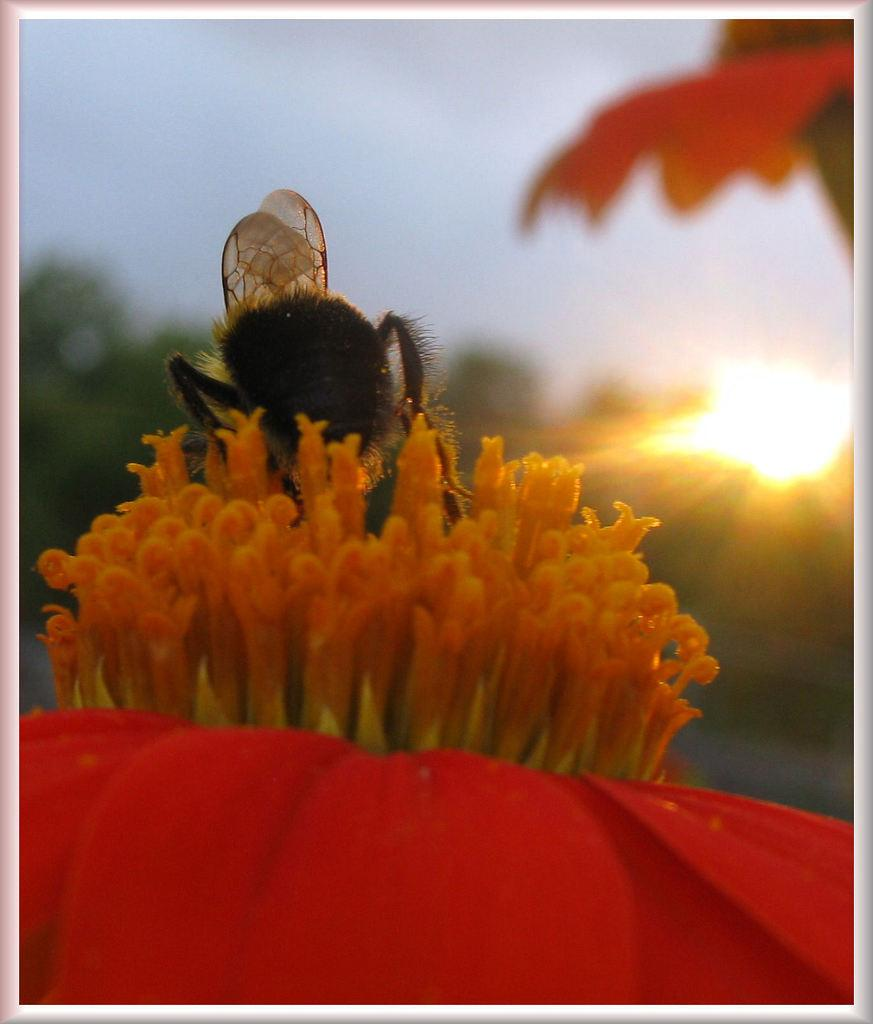What is the main subject of the image? There is a bee in the image. Where is the bee located in the image? The bee is sitting on pollen grains of a flower. What color are the petals of the flower? The flower has red color petals. How is the background of the image depicted? The backdrop of the image is blurred. What type of stew is being prepared in the image? There is no stew present in the image; it features a bee sitting on a flower. Is there any toothpaste visible in the image? There is no toothpaste present in the image. 